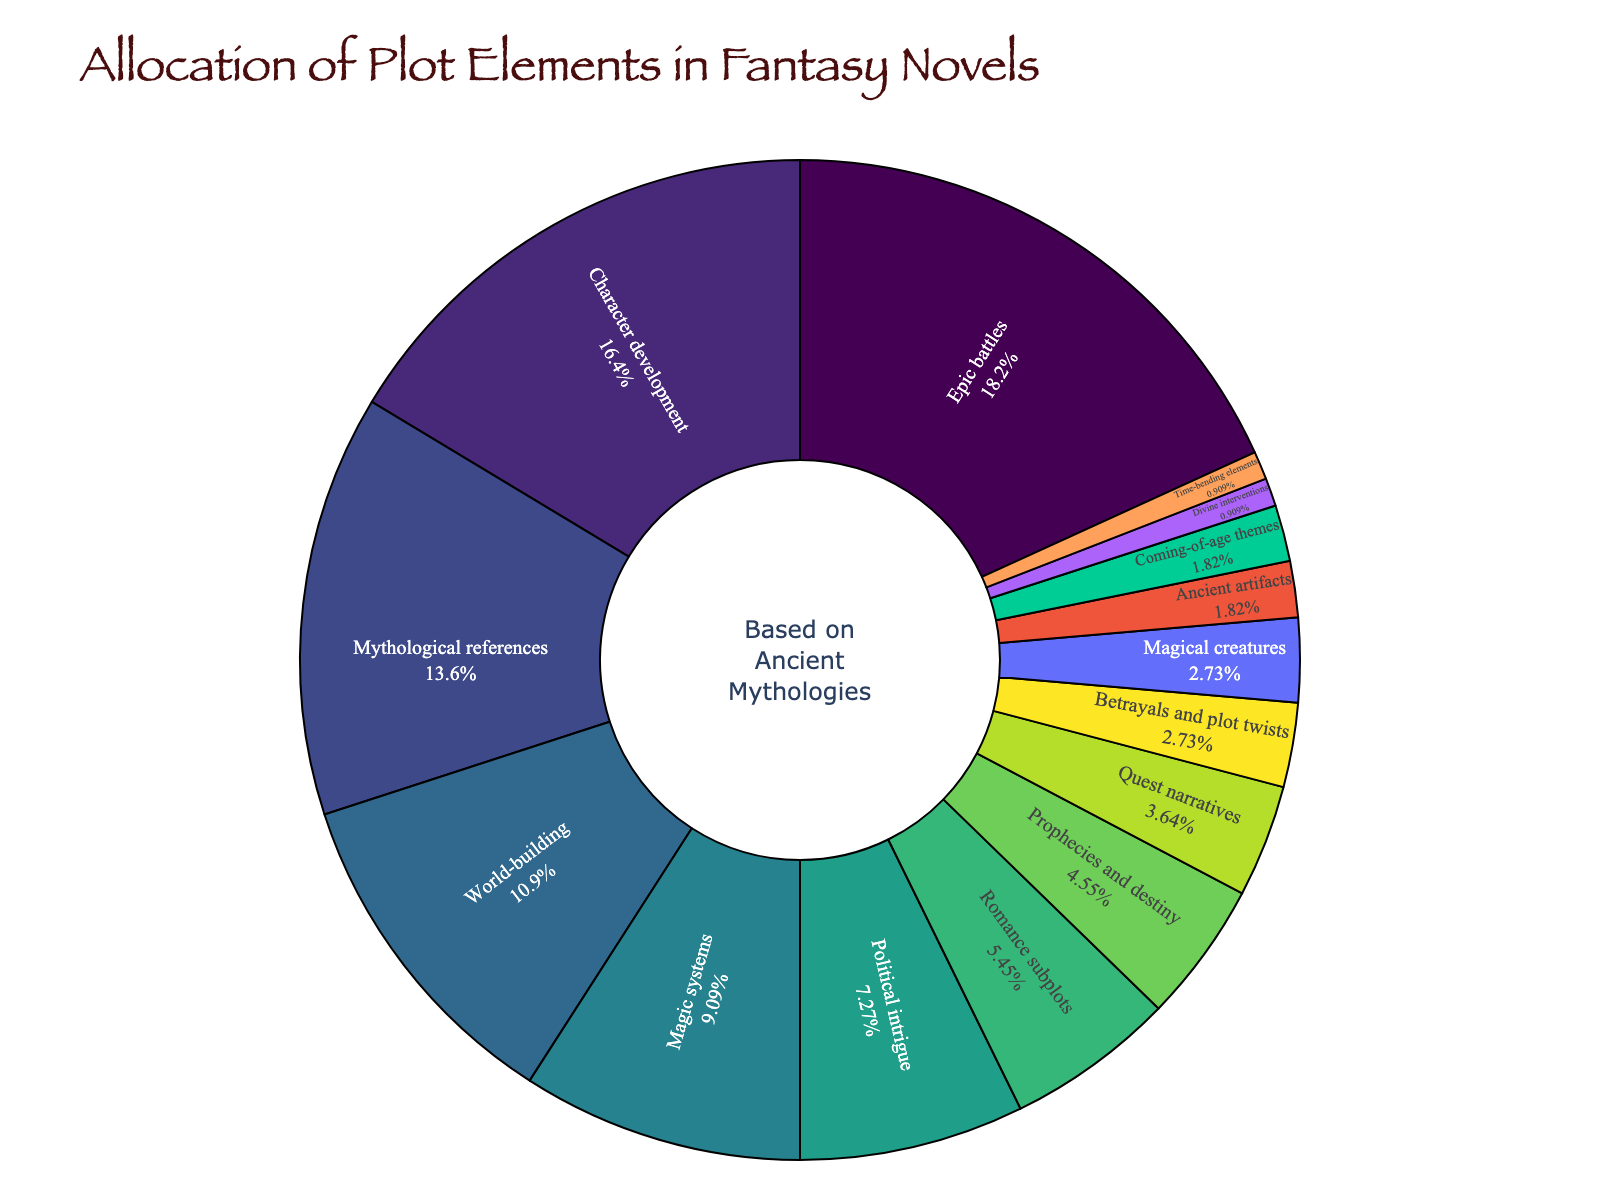which plot element occupies the largest percentage? The plot element with the largest percentage is determined by identifying the largest section of the pie chart and noting the label associated with it.
Answer: Epic battles how much larger is character development compared to romance subplots? Identify the percentages of character development (18%) and romance subplots (6%), then subtract the percentage of romance subplots from character development to find the difference. 18% - 6% = 12%.
Answer: 12% what is the combined percentage of magic systems and mythological references? Identify the percentages of magic systems (10%) and mythological references (15%), then add these two percentages together. 10% + 15% = 25%.
Answer: 25% which plot elements have the smallest allocations? The plot elements with the smallest allocations will be those with the smallest percentages. By observing the pie chart, the elements with the smallest percentages are divine interventions and time-bending elements.
Answer: Divine interventions, time-bending elements how does the allocation for world-building compare to the allocation for political intrigue? Identify the percentages for world-building (12%) and political intrigue (8%), and compare them. World-building has a higher percentage than political intrigue.
Answer: World-building is higher if you were to combine the allocation for coming-of-age themes, ancient artifacts, and divine interventions, what would the total percentage be? Identify the percentages for coming-of-age themes (2%), ancient artifacts (2%), and divine interventions (1%), then sum these percentages together. 2% + 2% + 1% = 5%.
Answer: 5% what percentage of the pie chart is taken up by elements related to quests and adventures (prophecies and destiny, quest narratives, and magical creatures)? Sum the percentages of prophecies and destiny (5%), quest narratives (4%), and magical creatures (3%). 5% + 4% + 3% = 12%.
Answer: 12% which visual section appears to be the smallest on the chart? The smallest section on the chart corresponds to the smallest percentage allocation, which is 1%. By observing the pie chart, the smallest sections are divine interventions and time-bending elements.
Answer: Divine interventions, time-bending elements 